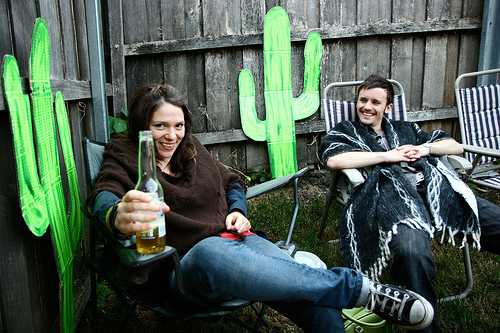<image>
Is the poncho next to the man? No. The poncho is not positioned next to the man. They are located in different areas of the scene. 